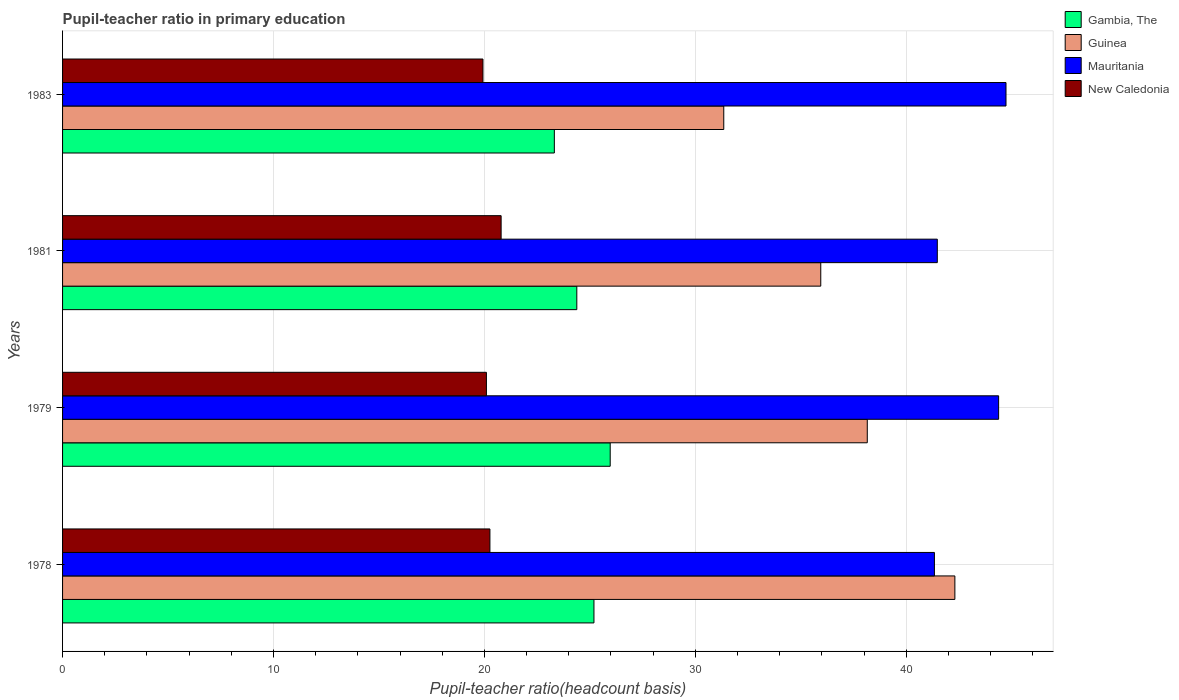How many groups of bars are there?
Make the answer very short. 4. Are the number of bars per tick equal to the number of legend labels?
Give a very brief answer. Yes. How many bars are there on the 4th tick from the top?
Make the answer very short. 4. What is the label of the 4th group of bars from the top?
Provide a succinct answer. 1978. What is the pupil-teacher ratio in primary education in Guinea in 1978?
Ensure brevity in your answer.  42.3. Across all years, what is the maximum pupil-teacher ratio in primary education in Gambia, The?
Your answer should be very brief. 25.96. Across all years, what is the minimum pupil-teacher ratio in primary education in Mauritania?
Provide a short and direct response. 41.33. In which year was the pupil-teacher ratio in primary education in Gambia, The maximum?
Make the answer very short. 1979. In which year was the pupil-teacher ratio in primary education in Gambia, The minimum?
Make the answer very short. 1983. What is the total pupil-teacher ratio in primary education in New Caledonia in the graph?
Your answer should be very brief. 81.08. What is the difference between the pupil-teacher ratio in primary education in Gambia, The in 1979 and that in 1981?
Your answer should be compact. 1.58. What is the difference between the pupil-teacher ratio in primary education in Mauritania in 1981 and the pupil-teacher ratio in primary education in New Caledonia in 1983?
Your answer should be compact. 21.54. What is the average pupil-teacher ratio in primary education in Gambia, The per year?
Offer a very short reply. 24.71. In the year 1979, what is the difference between the pupil-teacher ratio in primary education in Guinea and pupil-teacher ratio in primary education in Gambia, The?
Give a very brief answer. 12.19. In how many years, is the pupil-teacher ratio in primary education in Gambia, The greater than 32 ?
Your response must be concise. 0. What is the ratio of the pupil-teacher ratio in primary education in Guinea in 1981 to that in 1983?
Keep it short and to the point. 1.15. Is the pupil-teacher ratio in primary education in Guinea in 1978 less than that in 1983?
Your answer should be compact. No. Is the difference between the pupil-teacher ratio in primary education in Guinea in 1978 and 1979 greater than the difference between the pupil-teacher ratio in primary education in Gambia, The in 1978 and 1979?
Offer a very short reply. Yes. What is the difference between the highest and the second highest pupil-teacher ratio in primary education in New Caledonia?
Keep it short and to the point. 0.53. What is the difference between the highest and the lowest pupil-teacher ratio in primary education in New Caledonia?
Keep it short and to the point. 0.86. What does the 2nd bar from the top in 1979 represents?
Ensure brevity in your answer.  Mauritania. What does the 2nd bar from the bottom in 1983 represents?
Ensure brevity in your answer.  Guinea. Is it the case that in every year, the sum of the pupil-teacher ratio in primary education in New Caledonia and pupil-teacher ratio in primary education in Guinea is greater than the pupil-teacher ratio in primary education in Gambia, The?
Provide a short and direct response. Yes. How many years are there in the graph?
Keep it short and to the point. 4. What is the difference between two consecutive major ticks on the X-axis?
Offer a very short reply. 10. Are the values on the major ticks of X-axis written in scientific E-notation?
Your response must be concise. No. Does the graph contain any zero values?
Your answer should be very brief. No. What is the title of the graph?
Your answer should be very brief. Pupil-teacher ratio in primary education. What is the label or title of the X-axis?
Ensure brevity in your answer.  Pupil-teacher ratio(headcount basis). What is the Pupil-teacher ratio(headcount basis) of Gambia, The in 1978?
Your answer should be compact. 25.19. What is the Pupil-teacher ratio(headcount basis) in Guinea in 1978?
Ensure brevity in your answer.  42.3. What is the Pupil-teacher ratio(headcount basis) of Mauritania in 1978?
Ensure brevity in your answer.  41.33. What is the Pupil-teacher ratio(headcount basis) in New Caledonia in 1978?
Your answer should be compact. 20.26. What is the Pupil-teacher ratio(headcount basis) of Gambia, The in 1979?
Your response must be concise. 25.96. What is the Pupil-teacher ratio(headcount basis) in Guinea in 1979?
Keep it short and to the point. 38.15. What is the Pupil-teacher ratio(headcount basis) of Mauritania in 1979?
Keep it short and to the point. 44.38. What is the Pupil-teacher ratio(headcount basis) of New Caledonia in 1979?
Your response must be concise. 20.09. What is the Pupil-teacher ratio(headcount basis) in Gambia, The in 1981?
Provide a short and direct response. 24.38. What is the Pupil-teacher ratio(headcount basis) in Guinea in 1981?
Provide a short and direct response. 35.95. What is the Pupil-teacher ratio(headcount basis) in Mauritania in 1981?
Give a very brief answer. 41.47. What is the Pupil-teacher ratio(headcount basis) of New Caledonia in 1981?
Offer a very short reply. 20.79. What is the Pupil-teacher ratio(headcount basis) in Gambia, The in 1983?
Your response must be concise. 23.31. What is the Pupil-teacher ratio(headcount basis) in Guinea in 1983?
Offer a terse response. 31.35. What is the Pupil-teacher ratio(headcount basis) of Mauritania in 1983?
Offer a terse response. 44.73. What is the Pupil-teacher ratio(headcount basis) of New Caledonia in 1983?
Offer a terse response. 19.93. Across all years, what is the maximum Pupil-teacher ratio(headcount basis) of Gambia, The?
Provide a short and direct response. 25.96. Across all years, what is the maximum Pupil-teacher ratio(headcount basis) of Guinea?
Keep it short and to the point. 42.3. Across all years, what is the maximum Pupil-teacher ratio(headcount basis) in Mauritania?
Offer a very short reply. 44.73. Across all years, what is the maximum Pupil-teacher ratio(headcount basis) in New Caledonia?
Provide a succinct answer. 20.79. Across all years, what is the minimum Pupil-teacher ratio(headcount basis) in Gambia, The?
Ensure brevity in your answer.  23.31. Across all years, what is the minimum Pupil-teacher ratio(headcount basis) in Guinea?
Give a very brief answer. 31.35. Across all years, what is the minimum Pupil-teacher ratio(headcount basis) of Mauritania?
Make the answer very short. 41.33. Across all years, what is the minimum Pupil-teacher ratio(headcount basis) in New Caledonia?
Make the answer very short. 19.93. What is the total Pupil-teacher ratio(headcount basis) in Gambia, The in the graph?
Give a very brief answer. 98.85. What is the total Pupil-teacher ratio(headcount basis) of Guinea in the graph?
Ensure brevity in your answer.  147.75. What is the total Pupil-teacher ratio(headcount basis) of Mauritania in the graph?
Provide a short and direct response. 171.91. What is the total Pupil-teacher ratio(headcount basis) of New Caledonia in the graph?
Provide a succinct answer. 81.08. What is the difference between the Pupil-teacher ratio(headcount basis) of Gambia, The in 1978 and that in 1979?
Make the answer very short. -0.77. What is the difference between the Pupil-teacher ratio(headcount basis) in Guinea in 1978 and that in 1979?
Offer a very short reply. 4.15. What is the difference between the Pupil-teacher ratio(headcount basis) of Mauritania in 1978 and that in 1979?
Make the answer very short. -3.04. What is the difference between the Pupil-teacher ratio(headcount basis) of New Caledonia in 1978 and that in 1979?
Give a very brief answer. 0.17. What is the difference between the Pupil-teacher ratio(headcount basis) in Gambia, The in 1978 and that in 1981?
Provide a succinct answer. 0.81. What is the difference between the Pupil-teacher ratio(headcount basis) of Guinea in 1978 and that in 1981?
Provide a succinct answer. 6.36. What is the difference between the Pupil-teacher ratio(headcount basis) in Mauritania in 1978 and that in 1981?
Your response must be concise. -0.14. What is the difference between the Pupil-teacher ratio(headcount basis) in New Caledonia in 1978 and that in 1981?
Your response must be concise. -0.53. What is the difference between the Pupil-teacher ratio(headcount basis) in Gambia, The in 1978 and that in 1983?
Offer a very short reply. 1.88. What is the difference between the Pupil-teacher ratio(headcount basis) in Guinea in 1978 and that in 1983?
Ensure brevity in your answer.  10.96. What is the difference between the Pupil-teacher ratio(headcount basis) of Mauritania in 1978 and that in 1983?
Ensure brevity in your answer.  -3.39. What is the difference between the Pupil-teacher ratio(headcount basis) of New Caledonia in 1978 and that in 1983?
Keep it short and to the point. 0.33. What is the difference between the Pupil-teacher ratio(headcount basis) of Gambia, The in 1979 and that in 1981?
Your answer should be compact. 1.58. What is the difference between the Pupil-teacher ratio(headcount basis) in Guinea in 1979 and that in 1981?
Keep it short and to the point. 2.21. What is the difference between the Pupil-teacher ratio(headcount basis) in Mauritania in 1979 and that in 1981?
Your answer should be very brief. 2.91. What is the difference between the Pupil-teacher ratio(headcount basis) in New Caledonia in 1979 and that in 1981?
Your answer should be compact. -0.7. What is the difference between the Pupil-teacher ratio(headcount basis) of Gambia, The in 1979 and that in 1983?
Make the answer very short. 2.65. What is the difference between the Pupil-teacher ratio(headcount basis) of Guinea in 1979 and that in 1983?
Your answer should be compact. 6.8. What is the difference between the Pupil-teacher ratio(headcount basis) in Mauritania in 1979 and that in 1983?
Your response must be concise. -0.35. What is the difference between the Pupil-teacher ratio(headcount basis) in New Caledonia in 1979 and that in 1983?
Keep it short and to the point. 0.16. What is the difference between the Pupil-teacher ratio(headcount basis) of Gambia, The in 1981 and that in 1983?
Provide a short and direct response. 1.06. What is the difference between the Pupil-teacher ratio(headcount basis) in Guinea in 1981 and that in 1983?
Keep it short and to the point. 4.6. What is the difference between the Pupil-teacher ratio(headcount basis) in Mauritania in 1981 and that in 1983?
Provide a short and direct response. -3.26. What is the difference between the Pupil-teacher ratio(headcount basis) in New Caledonia in 1981 and that in 1983?
Offer a very short reply. 0.86. What is the difference between the Pupil-teacher ratio(headcount basis) in Gambia, The in 1978 and the Pupil-teacher ratio(headcount basis) in Guinea in 1979?
Provide a short and direct response. -12.96. What is the difference between the Pupil-teacher ratio(headcount basis) in Gambia, The in 1978 and the Pupil-teacher ratio(headcount basis) in Mauritania in 1979?
Keep it short and to the point. -19.18. What is the difference between the Pupil-teacher ratio(headcount basis) of Gambia, The in 1978 and the Pupil-teacher ratio(headcount basis) of New Caledonia in 1979?
Give a very brief answer. 5.1. What is the difference between the Pupil-teacher ratio(headcount basis) of Guinea in 1978 and the Pupil-teacher ratio(headcount basis) of Mauritania in 1979?
Offer a terse response. -2.07. What is the difference between the Pupil-teacher ratio(headcount basis) in Guinea in 1978 and the Pupil-teacher ratio(headcount basis) in New Caledonia in 1979?
Your answer should be very brief. 22.21. What is the difference between the Pupil-teacher ratio(headcount basis) of Mauritania in 1978 and the Pupil-teacher ratio(headcount basis) of New Caledonia in 1979?
Give a very brief answer. 21.24. What is the difference between the Pupil-teacher ratio(headcount basis) in Gambia, The in 1978 and the Pupil-teacher ratio(headcount basis) in Guinea in 1981?
Your response must be concise. -10.75. What is the difference between the Pupil-teacher ratio(headcount basis) in Gambia, The in 1978 and the Pupil-teacher ratio(headcount basis) in Mauritania in 1981?
Your response must be concise. -16.28. What is the difference between the Pupil-teacher ratio(headcount basis) of Gambia, The in 1978 and the Pupil-teacher ratio(headcount basis) of New Caledonia in 1981?
Offer a terse response. 4.4. What is the difference between the Pupil-teacher ratio(headcount basis) of Guinea in 1978 and the Pupil-teacher ratio(headcount basis) of Mauritania in 1981?
Provide a succinct answer. 0.83. What is the difference between the Pupil-teacher ratio(headcount basis) in Guinea in 1978 and the Pupil-teacher ratio(headcount basis) in New Caledonia in 1981?
Provide a short and direct response. 21.51. What is the difference between the Pupil-teacher ratio(headcount basis) of Mauritania in 1978 and the Pupil-teacher ratio(headcount basis) of New Caledonia in 1981?
Offer a terse response. 20.54. What is the difference between the Pupil-teacher ratio(headcount basis) of Gambia, The in 1978 and the Pupil-teacher ratio(headcount basis) of Guinea in 1983?
Provide a succinct answer. -6.15. What is the difference between the Pupil-teacher ratio(headcount basis) in Gambia, The in 1978 and the Pupil-teacher ratio(headcount basis) in Mauritania in 1983?
Offer a terse response. -19.54. What is the difference between the Pupil-teacher ratio(headcount basis) in Gambia, The in 1978 and the Pupil-teacher ratio(headcount basis) in New Caledonia in 1983?
Offer a terse response. 5.26. What is the difference between the Pupil-teacher ratio(headcount basis) of Guinea in 1978 and the Pupil-teacher ratio(headcount basis) of Mauritania in 1983?
Offer a terse response. -2.42. What is the difference between the Pupil-teacher ratio(headcount basis) of Guinea in 1978 and the Pupil-teacher ratio(headcount basis) of New Caledonia in 1983?
Your answer should be compact. 22.37. What is the difference between the Pupil-teacher ratio(headcount basis) in Mauritania in 1978 and the Pupil-teacher ratio(headcount basis) in New Caledonia in 1983?
Provide a short and direct response. 21.4. What is the difference between the Pupil-teacher ratio(headcount basis) in Gambia, The in 1979 and the Pupil-teacher ratio(headcount basis) in Guinea in 1981?
Offer a terse response. -9.98. What is the difference between the Pupil-teacher ratio(headcount basis) in Gambia, The in 1979 and the Pupil-teacher ratio(headcount basis) in Mauritania in 1981?
Keep it short and to the point. -15.51. What is the difference between the Pupil-teacher ratio(headcount basis) in Gambia, The in 1979 and the Pupil-teacher ratio(headcount basis) in New Caledonia in 1981?
Give a very brief answer. 5.17. What is the difference between the Pupil-teacher ratio(headcount basis) of Guinea in 1979 and the Pupil-teacher ratio(headcount basis) of Mauritania in 1981?
Offer a terse response. -3.32. What is the difference between the Pupil-teacher ratio(headcount basis) of Guinea in 1979 and the Pupil-teacher ratio(headcount basis) of New Caledonia in 1981?
Make the answer very short. 17.36. What is the difference between the Pupil-teacher ratio(headcount basis) of Mauritania in 1979 and the Pupil-teacher ratio(headcount basis) of New Caledonia in 1981?
Your response must be concise. 23.59. What is the difference between the Pupil-teacher ratio(headcount basis) of Gambia, The in 1979 and the Pupil-teacher ratio(headcount basis) of Guinea in 1983?
Offer a terse response. -5.38. What is the difference between the Pupil-teacher ratio(headcount basis) in Gambia, The in 1979 and the Pupil-teacher ratio(headcount basis) in Mauritania in 1983?
Keep it short and to the point. -18.76. What is the difference between the Pupil-teacher ratio(headcount basis) in Gambia, The in 1979 and the Pupil-teacher ratio(headcount basis) in New Caledonia in 1983?
Your answer should be very brief. 6.03. What is the difference between the Pupil-teacher ratio(headcount basis) of Guinea in 1979 and the Pupil-teacher ratio(headcount basis) of Mauritania in 1983?
Your response must be concise. -6.58. What is the difference between the Pupil-teacher ratio(headcount basis) of Guinea in 1979 and the Pupil-teacher ratio(headcount basis) of New Caledonia in 1983?
Give a very brief answer. 18.22. What is the difference between the Pupil-teacher ratio(headcount basis) in Mauritania in 1979 and the Pupil-teacher ratio(headcount basis) in New Caledonia in 1983?
Offer a very short reply. 24.45. What is the difference between the Pupil-teacher ratio(headcount basis) of Gambia, The in 1981 and the Pupil-teacher ratio(headcount basis) of Guinea in 1983?
Your answer should be compact. -6.97. What is the difference between the Pupil-teacher ratio(headcount basis) of Gambia, The in 1981 and the Pupil-teacher ratio(headcount basis) of Mauritania in 1983?
Provide a short and direct response. -20.35. What is the difference between the Pupil-teacher ratio(headcount basis) in Gambia, The in 1981 and the Pupil-teacher ratio(headcount basis) in New Caledonia in 1983?
Your answer should be very brief. 4.45. What is the difference between the Pupil-teacher ratio(headcount basis) of Guinea in 1981 and the Pupil-teacher ratio(headcount basis) of Mauritania in 1983?
Make the answer very short. -8.78. What is the difference between the Pupil-teacher ratio(headcount basis) of Guinea in 1981 and the Pupil-teacher ratio(headcount basis) of New Caledonia in 1983?
Give a very brief answer. 16.02. What is the difference between the Pupil-teacher ratio(headcount basis) of Mauritania in 1981 and the Pupil-teacher ratio(headcount basis) of New Caledonia in 1983?
Offer a very short reply. 21.54. What is the average Pupil-teacher ratio(headcount basis) in Gambia, The per year?
Keep it short and to the point. 24.71. What is the average Pupil-teacher ratio(headcount basis) in Guinea per year?
Give a very brief answer. 36.94. What is the average Pupil-teacher ratio(headcount basis) in Mauritania per year?
Your response must be concise. 42.98. What is the average Pupil-teacher ratio(headcount basis) of New Caledonia per year?
Your answer should be very brief. 20.27. In the year 1978, what is the difference between the Pupil-teacher ratio(headcount basis) in Gambia, The and Pupil-teacher ratio(headcount basis) in Guinea?
Provide a short and direct response. -17.11. In the year 1978, what is the difference between the Pupil-teacher ratio(headcount basis) in Gambia, The and Pupil-teacher ratio(headcount basis) in Mauritania?
Provide a short and direct response. -16.14. In the year 1978, what is the difference between the Pupil-teacher ratio(headcount basis) of Gambia, The and Pupil-teacher ratio(headcount basis) of New Caledonia?
Make the answer very short. 4.93. In the year 1978, what is the difference between the Pupil-teacher ratio(headcount basis) of Guinea and Pupil-teacher ratio(headcount basis) of Mauritania?
Provide a short and direct response. 0.97. In the year 1978, what is the difference between the Pupil-teacher ratio(headcount basis) of Guinea and Pupil-teacher ratio(headcount basis) of New Caledonia?
Your response must be concise. 22.04. In the year 1978, what is the difference between the Pupil-teacher ratio(headcount basis) of Mauritania and Pupil-teacher ratio(headcount basis) of New Caledonia?
Make the answer very short. 21.07. In the year 1979, what is the difference between the Pupil-teacher ratio(headcount basis) in Gambia, The and Pupil-teacher ratio(headcount basis) in Guinea?
Offer a very short reply. -12.19. In the year 1979, what is the difference between the Pupil-teacher ratio(headcount basis) in Gambia, The and Pupil-teacher ratio(headcount basis) in Mauritania?
Offer a very short reply. -18.41. In the year 1979, what is the difference between the Pupil-teacher ratio(headcount basis) of Gambia, The and Pupil-teacher ratio(headcount basis) of New Caledonia?
Your answer should be compact. 5.87. In the year 1979, what is the difference between the Pupil-teacher ratio(headcount basis) in Guinea and Pupil-teacher ratio(headcount basis) in Mauritania?
Keep it short and to the point. -6.23. In the year 1979, what is the difference between the Pupil-teacher ratio(headcount basis) in Guinea and Pupil-teacher ratio(headcount basis) in New Caledonia?
Make the answer very short. 18.06. In the year 1979, what is the difference between the Pupil-teacher ratio(headcount basis) of Mauritania and Pupil-teacher ratio(headcount basis) of New Caledonia?
Keep it short and to the point. 24.28. In the year 1981, what is the difference between the Pupil-teacher ratio(headcount basis) of Gambia, The and Pupil-teacher ratio(headcount basis) of Guinea?
Provide a succinct answer. -11.57. In the year 1981, what is the difference between the Pupil-teacher ratio(headcount basis) of Gambia, The and Pupil-teacher ratio(headcount basis) of Mauritania?
Make the answer very short. -17.09. In the year 1981, what is the difference between the Pupil-teacher ratio(headcount basis) in Gambia, The and Pupil-teacher ratio(headcount basis) in New Caledonia?
Your answer should be compact. 3.59. In the year 1981, what is the difference between the Pupil-teacher ratio(headcount basis) of Guinea and Pupil-teacher ratio(headcount basis) of Mauritania?
Provide a short and direct response. -5.53. In the year 1981, what is the difference between the Pupil-teacher ratio(headcount basis) of Guinea and Pupil-teacher ratio(headcount basis) of New Caledonia?
Provide a short and direct response. 15.15. In the year 1981, what is the difference between the Pupil-teacher ratio(headcount basis) in Mauritania and Pupil-teacher ratio(headcount basis) in New Caledonia?
Your response must be concise. 20.68. In the year 1983, what is the difference between the Pupil-teacher ratio(headcount basis) in Gambia, The and Pupil-teacher ratio(headcount basis) in Guinea?
Give a very brief answer. -8.03. In the year 1983, what is the difference between the Pupil-teacher ratio(headcount basis) in Gambia, The and Pupil-teacher ratio(headcount basis) in Mauritania?
Your answer should be compact. -21.41. In the year 1983, what is the difference between the Pupil-teacher ratio(headcount basis) in Gambia, The and Pupil-teacher ratio(headcount basis) in New Caledonia?
Keep it short and to the point. 3.38. In the year 1983, what is the difference between the Pupil-teacher ratio(headcount basis) of Guinea and Pupil-teacher ratio(headcount basis) of Mauritania?
Your answer should be very brief. -13.38. In the year 1983, what is the difference between the Pupil-teacher ratio(headcount basis) in Guinea and Pupil-teacher ratio(headcount basis) in New Caledonia?
Your answer should be very brief. 11.42. In the year 1983, what is the difference between the Pupil-teacher ratio(headcount basis) of Mauritania and Pupil-teacher ratio(headcount basis) of New Caledonia?
Keep it short and to the point. 24.8. What is the ratio of the Pupil-teacher ratio(headcount basis) in Gambia, The in 1978 to that in 1979?
Keep it short and to the point. 0.97. What is the ratio of the Pupil-teacher ratio(headcount basis) in Guinea in 1978 to that in 1979?
Your answer should be compact. 1.11. What is the ratio of the Pupil-teacher ratio(headcount basis) in Mauritania in 1978 to that in 1979?
Offer a very short reply. 0.93. What is the ratio of the Pupil-teacher ratio(headcount basis) of New Caledonia in 1978 to that in 1979?
Ensure brevity in your answer.  1.01. What is the ratio of the Pupil-teacher ratio(headcount basis) of Gambia, The in 1978 to that in 1981?
Your answer should be compact. 1.03. What is the ratio of the Pupil-teacher ratio(headcount basis) of Guinea in 1978 to that in 1981?
Give a very brief answer. 1.18. What is the ratio of the Pupil-teacher ratio(headcount basis) in Mauritania in 1978 to that in 1981?
Offer a terse response. 1. What is the ratio of the Pupil-teacher ratio(headcount basis) in New Caledonia in 1978 to that in 1981?
Make the answer very short. 0.97. What is the ratio of the Pupil-teacher ratio(headcount basis) of Gambia, The in 1978 to that in 1983?
Provide a succinct answer. 1.08. What is the ratio of the Pupil-teacher ratio(headcount basis) of Guinea in 1978 to that in 1983?
Offer a terse response. 1.35. What is the ratio of the Pupil-teacher ratio(headcount basis) in Mauritania in 1978 to that in 1983?
Your answer should be compact. 0.92. What is the ratio of the Pupil-teacher ratio(headcount basis) in New Caledonia in 1978 to that in 1983?
Provide a short and direct response. 1.02. What is the ratio of the Pupil-teacher ratio(headcount basis) of Gambia, The in 1979 to that in 1981?
Make the answer very short. 1.06. What is the ratio of the Pupil-teacher ratio(headcount basis) in Guinea in 1979 to that in 1981?
Give a very brief answer. 1.06. What is the ratio of the Pupil-teacher ratio(headcount basis) of Mauritania in 1979 to that in 1981?
Your answer should be very brief. 1.07. What is the ratio of the Pupil-teacher ratio(headcount basis) in New Caledonia in 1979 to that in 1981?
Make the answer very short. 0.97. What is the ratio of the Pupil-teacher ratio(headcount basis) of Gambia, The in 1979 to that in 1983?
Provide a succinct answer. 1.11. What is the ratio of the Pupil-teacher ratio(headcount basis) of Guinea in 1979 to that in 1983?
Keep it short and to the point. 1.22. What is the ratio of the Pupil-teacher ratio(headcount basis) in New Caledonia in 1979 to that in 1983?
Offer a terse response. 1.01. What is the ratio of the Pupil-teacher ratio(headcount basis) of Gambia, The in 1981 to that in 1983?
Make the answer very short. 1.05. What is the ratio of the Pupil-teacher ratio(headcount basis) of Guinea in 1981 to that in 1983?
Offer a very short reply. 1.15. What is the ratio of the Pupil-teacher ratio(headcount basis) in Mauritania in 1981 to that in 1983?
Keep it short and to the point. 0.93. What is the ratio of the Pupil-teacher ratio(headcount basis) of New Caledonia in 1981 to that in 1983?
Keep it short and to the point. 1.04. What is the difference between the highest and the second highest Pupil-teacher ratio(headcount basis) in Gambia, The?
Provide a short and direct response. 0.77. What is the difference between the highest and the second highest Pupil-teacher ratio(headcount basis) in Guinea?
Offer a terse response. 4.15. What is the difference between the highest and the second highest Pupil-teacher ratio(headcount basis) of Mauritania?
Give a very brief answer. 0.35. What is the difference between the highest and the second highest Pupil-teacher ratio(headcount basis) of New Caledonia?
Provide a short and direct response. 0.53. What is the difference between the highest and the lowest Pupil-teacher ratio(headcount basis) of Gambia, The?
Provide a succinct answer. 2.65. What is the difference between the highest and the lowest Pupil-teacher ratio(headcount basis) in Guinea?
Your answer should be very brief. 10.96. What is the difference between the highest and the lowest Pupil-teacher ratio(headcount basis) of Mauritania?
Your answer should be compact. 3.39. What is the difference between the highest and the lowest Pupil-teacher ratio(headcount basis) in New Caledonia?
Ensure brevity in your answer.  0.86. 